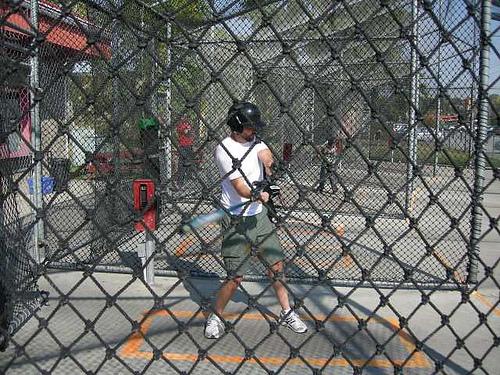What sport is the training for?
Keep it brief. Baseball. Where are the players?
Answer briefly. Batting cage. Is the guy inside a cage?
Answer briefly. Yes. Is the man wearing a long-sleeved shirt?
Keep it brief. No. 